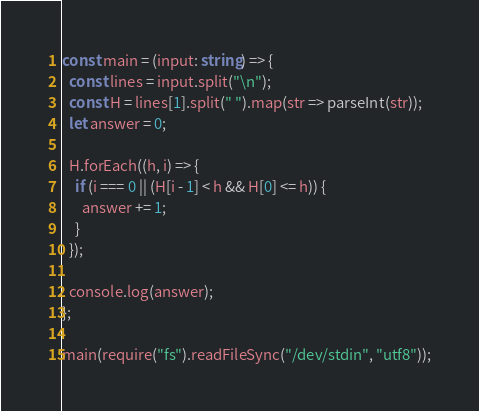Convert code to text. <code><loc_0><loc_0><loc_500><loc_500><_TypeScript_>const main = (input: string) => {
  const lines = input.split("\n");
  const H = lines[1].split(" ").map(str => parseInt(str));
  let answer = 0;

  H.forEach((h, i) => {
    if (i === 0 || (H[i - 1] < h && H[0] <= h)) {
      answer += 1;
    }
  });

  console.log(answer);
};

main(require("fs").readFileSync("/dev/stdin", "utf8"));
</code> 